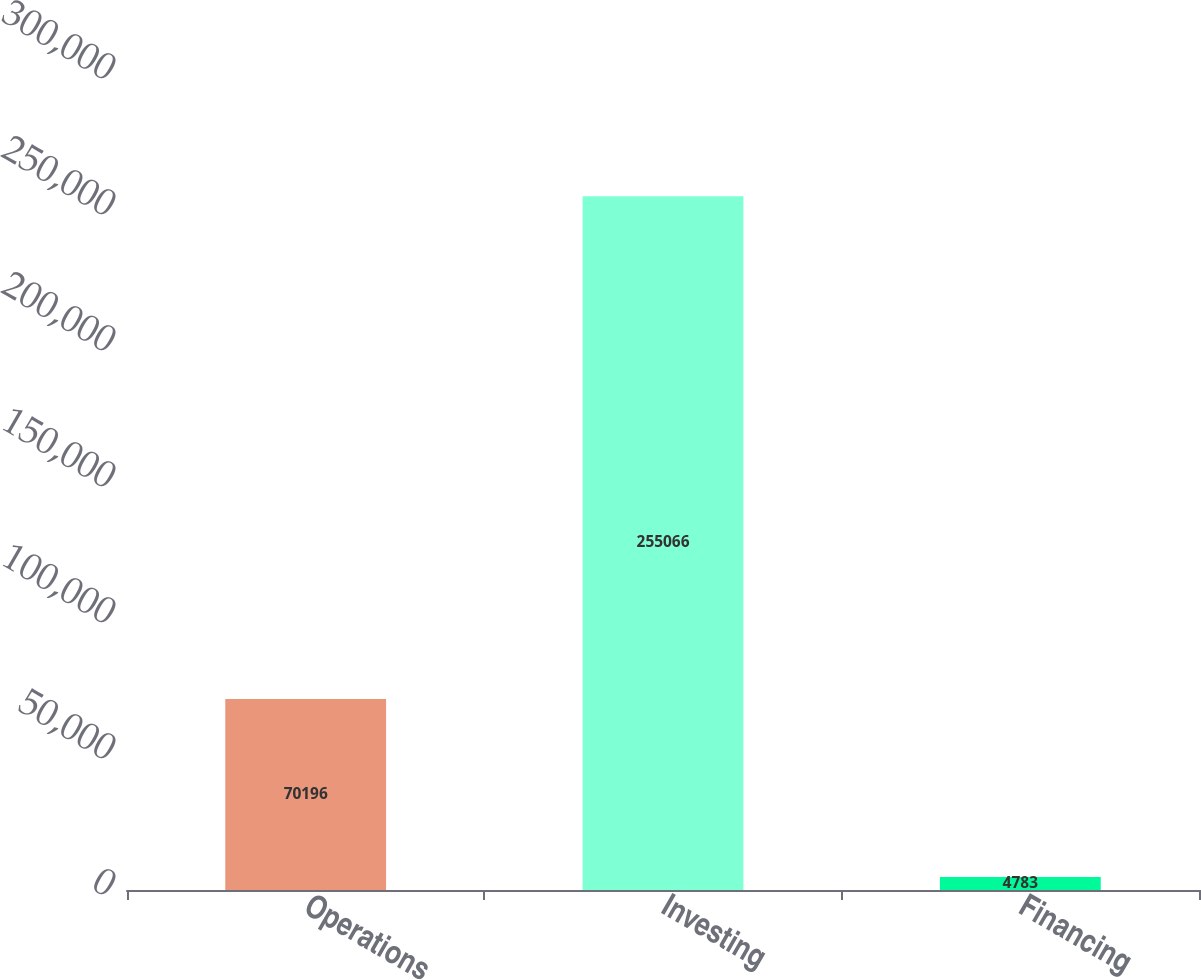<chart> <loc_0><loc_0><loc_500><loc_500><bar_chart><fcel>Operations<fcel>Investing<fcel>Financing<nl><fcel>70196<fcel>255066<fcel>4783<nl></chart> 